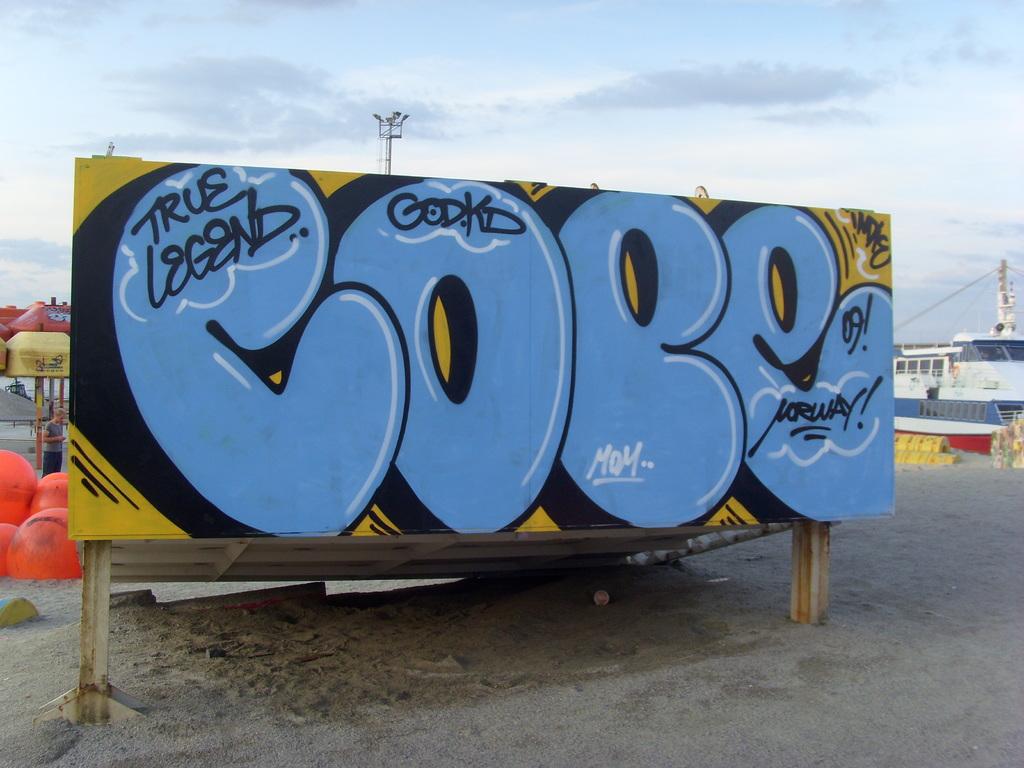What text is at the top of the board in black?
Ensure brevity in your answer.  True legend. 